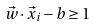<formula> <loc_0><loc_0><loc_500><loc_500>\vec { w } \cdot \vec { x } _ { i } - b \geq 1</formula> 